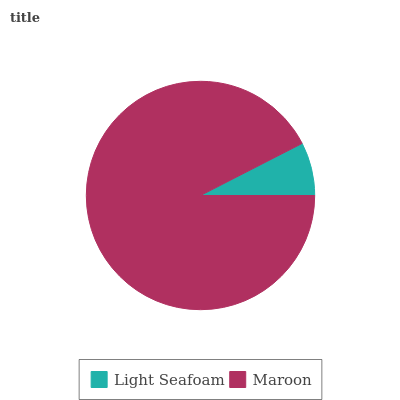Is Light Seafoam the minimum?
Answer yes or no. Yes. Is Maroon the maximum?
Answer yes or no. Yes. Is Maroon the minimum?
Answer yes or no. No. Is Maroon greater than Light Seafoam?
Answer yes or no. Yes. Is Light Seafoam less than Maroon?
Answer yes or no. Yes. Is Light Seafoam greater than Maroon?
Answer yes or no. No. Is Maroon less than Light Seafoam?
Answer yes or no. No. Is Maroon the high median?
Answer yes or no. Yes. Is Light Seafoam the low median?
Answer yes or no. Yes. Is Light Seafoam the high median?
Answer yes or no. No. Is Maroon the low median?
Answer yes or no. No. 